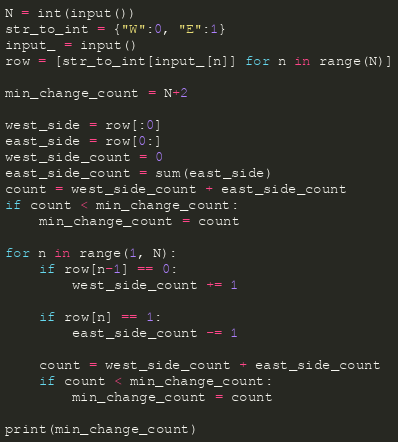<code> <loc_0><loc_0><loc_500><loc_500><_Python_>N = int(input())
str_to_int = {"W":0, "E":1}
input_ = input()
row = [str_to_int[input_[n]] for n in range(N)]

min_change_count = N+2

west_side = row[:0]
east_side = row[0:]
west_side_count = 0
east_side_count = sum(east_side)
count = west_side_count + east_side_count
if count < min_change_count:
    min_change_count = count
    
for n in range(1, N):
    if row[n-1] == 0:
        west_side_count += 1
        
    if row[n] == 1:
        east_side_count -= 1
        
    count = west_side_count + east_side_count
    if count < min_change_count:
        min_change_count = count
        
print(min_change_count)</code> 